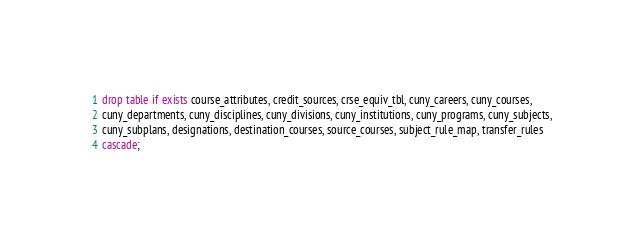<code> <loc_0><loc_0><loc_500><loc_500><_SQL_>drop table if exists course_attributes, credit_sources, crse_equiv_tbl, cuny_careers, cuny_courses,
cuny_departments, cuny_disciplines, cuny_divisions, cuny_institutions, cuny_programs, cuny_subjects,
cuny_subplans, designations, destination_courses, source_courses, subject_rule_map, transfer_rules
cascade;
</code> 